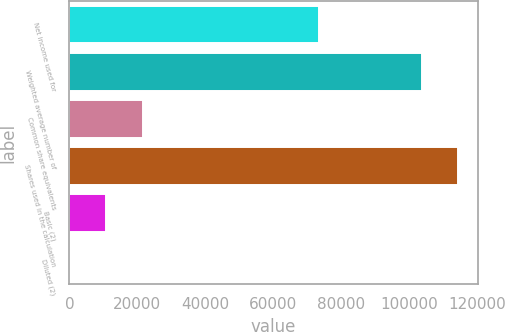Convert chart to OTSL. <chart><loc_0><loc_0><loc_500><loc_500><bar_chart><fcel>Net income used for<fcel>Weighted average number of<fcel>Common share equivalents<fcel>Shares used in the calculation<fcel>Basic (2)<fcel>Diluted (2)<nl><fcel>73553<fcel>103613<fcel>21666.1<fcel>114446<fcel>10833.4<fcel>0.68<nl></chart> 